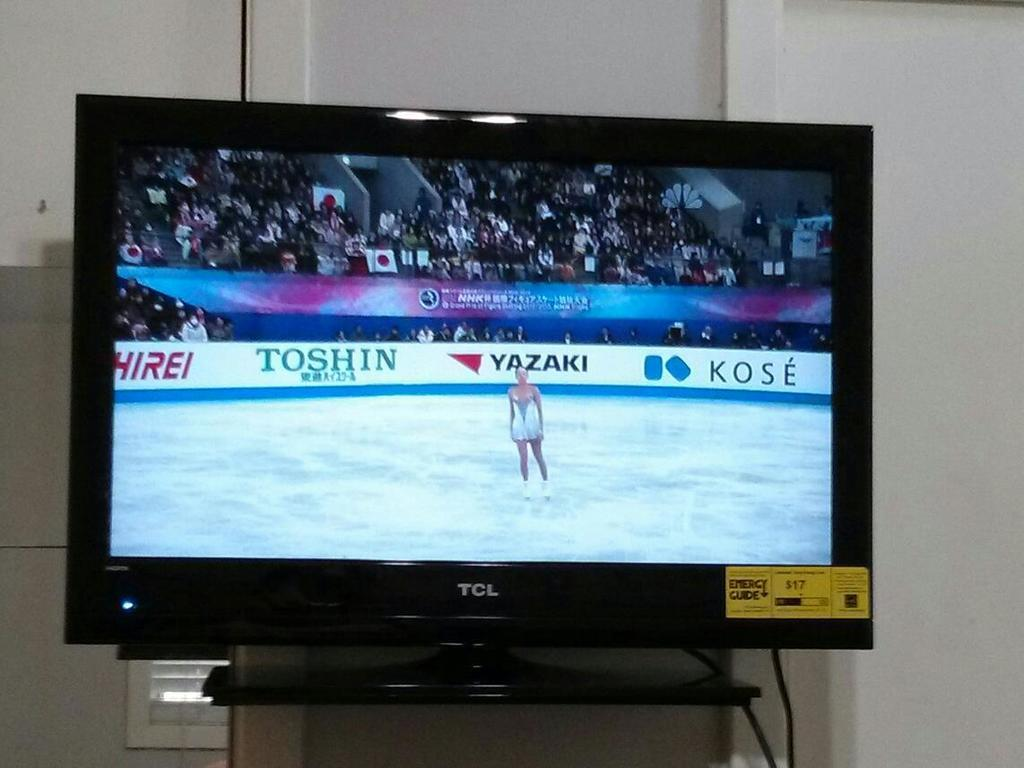<image>
Summarize the visual content of the image. The tv screen showing the ice dancer was made by TCL. 